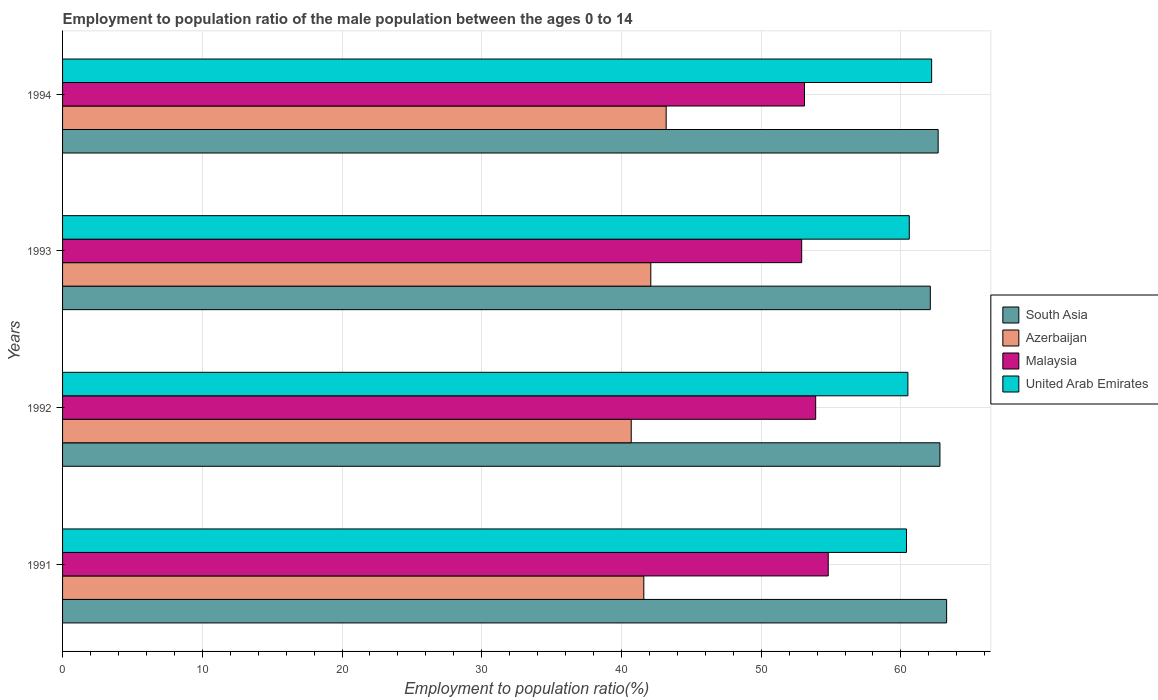How many groups of bars are there?
Offer a terse response. 4. How many bars are there on the 3rd tick from the top?
Your answer should be very brief. 4. In how many cases, is the number of bars for a given year not equal to the number of legend labels?
Keep it short and to the point. 0. What is the employment to population ratio in United Arab Emirates in 1992?
Keep it short and to the point. 60.5. Across all years, what is the maximum employment to population ratio in Malaysia?
Your answer should be compact. 54.8. Across all years, what is the minimum employment to population ratio in United Arab Emirates?
Ensure brevity in your answer.  60.4. In which year was the employment to population ratio in United Arab Emirates maximum?
Your answer should be very brief. 1994. What is the total employment to population ratio in South Asia in the graph?
Make the answer very short. 250.84. What is the difference between the employment to population ratio in Malaysia in 1992 and that in 1993?
Your answer should be very brief. 1. What is the difference between the employment to population ratio in United Arab Emirates in 1992 and the employment to population ratio in Malaysia in 1991?
Offer a very short reply. 5.7. What is the average employment to population ratio in United Arab Emirates per year?
Offer a very short reply. 60.93. In the year 1993, what is the difference between the employment to population ratio in United Arab Emirates and employment to population ratio in Malaysia?
Your answer should be very brief. 7.7. What is the ratio of the employment to population ratio in Malaysia in 1992 to that in 1994?
Ensure brevity in your answer.  1.02. Is the difference between the employment to population ratio in United Arab Emirates in 1991 and 1994 greater than the difference between the employment to population ratio in Malaysia in 1991 and 1994?
Your response must be concise. No. What is the difference between the highest and the second highest employment to population ratio in Azerbaijan?
Give a very brief answer. 1.1. What is the difference between the highest and the lowest employment to population ratio in Malaysia?
Give a very brief answer. 1.9. Is the sum of the employment to population ratio in Malaysia in 1992 and 1994 greater than the maximum employment to population ratio in Azerbaijan across all years?
Your answer should be very brief. Yes. What does the 4th bar from the top in 1991 represents?
Offer a very short reply. South Asia. What does the 3rd bar from the bottom in 1991 represents?
Offer a very short reply. Malaysia. How many bars are there?
Your answer should be compact. 16. Are all the bars in the graph horizontal?
Offer a terse response. Yes. What is the difference between two consecutive major ticks on the X-axis?
Offer a terse response. 10. Does the graph contain any zero values?
Make the answer very short. No. Where does the legend appear in the graph?
Provide a succinct answer. Center right. How many legend labels are there?
Provide a short and direct response. 4. What is the title of the graph?
Make the answer very short. Employment to population ratio of the male population between the ages 0 to 14. Does "North America" appear as one of the legend labels in the graph?
Your response must be concise. No. What is the Employment to population ratio(%) of South Asia in 1991?
Offer a very short reply. 63.27. What is the Employment to population ratio(%) of Azerbaijan in 1991?
Your answer should be very brief. 41.6. What is the Employment to population ratio(%) in Malaysia in 1991?
Provide a short and direct response. 54.8. What is the Employment to population ratio(%) in United Arab Emirates in 1991?
Make the answer very short. 60.4. What is the Employment to population ratio(%) of South Asia in 1992?
Keep it short and to the point. 62.79. What is the Employment to population ratio(%) of Azerbaijan in 1992?
Give a very brief answer. 40.7. What is the Employment to population ratio(%) of Malaysia in 1992?
Ensure brevity in your answer.  53.9. What is the Employment to population ratio(%) of United Arab Emirates in 1992?
Make the answer very short. 60.5. What is the Employment to population ratio(%) in South Asia in 1993?
Your answer should be very brief. 62.11. What is the Employment to population ratio(%) in Azerbaijan in 1993?
Your answer should be compact. 42.1. What is the Employment to population ratio(%) of Malaysia in 1993?
Provide a short and direct response. 52.9. What is the Employment to population ratio(%) of United Arab Emirates in 1993?
Give a very brief answer. 60.6. What is the Employment to population ratio(%) in South Asia in 1994?
Give a very brief answer. 62.67. What is the Employment to population ratio(%) in Azerbaijan in 1994?
Provide a succinct answer. 43.2. What is the Employment to population ratio(%) in Malaysia in 1994?
Your response must be concise. 53.1. What is the Employment to population ratio(%) of United Arab Emirates in 1994?
Give a very brief answer. 62.2. Across all years, what is the maximum Employment to population ratio(%) of South Asia?
Offer a very short reply. 63.27. Across all years, what is the maximum Employment to population ratio(%) in Azerbaijan?
Provide a short and direct response. 43.2. Across all years, what is the maximum Employment to population ratio(%) in Malaysia?
Your answer should be compact. 54.8. Across all years, what is the maximum Employment to population ratio(%) in United Arab Emirates?
Give a very brief answer. 62.2. Across all years, what is the minimum Employment to population ratio(%) in South Asia?
Ensure brevity in your answer.  62.11. Across all years, what is the minimum Employment to population ratio(%) in Azerbaijan?
Provide a short and direct response. 40.7. Across all years, what is the minimum Employment to population ratio(%) of Malaysia?
Your answer should be very brief. 52.9. Across all years, what is the minimum Employment to population ratio(%) of United Arab Emirates?
Your response must be concise. 60.4. What is the total Employment to population ratio(%) in South Asia in the graph?
Your answer should be compact. 250.84. What is the total Employment to population ratio(%) of Azerbaijan in the graph?
Your response must be concise. 167.6. What is the total Employment to population ratio(%) of Malaysia in the graph?
Your response must be concise. 214.7. What is the total Employment to population ratio(%) of United Arab Emirates in the graph?
Provide a short and direct response. 243.7. What is the difference between the Employment to population ratio(%) of South Asia in 1991 and that in 1992?
Provide a short and direct response. 0.48. What is the difference between the Employment to population ratio(%) of Malaysia in 1991 and that in 1992?
Make the answer very short. 0.9. What is the difference between the Employment to population ratio(%) in South Asia in 1991 and that in 1993?
Make the answer very short. 1.17. What is the difference between the Employment to population ratio(%) in United Arab Emirates in 1991 and that in 1993?
Your answer should be compact. -0.2. What is the difference between the Employment to population ratio(%) in South Asia in 1991 and that in 1994?
Make the answer very short. 0.61. What is the difference between the Employment to population ratio(%) of United Arab Emirates in 1991 and that in 1994?
Offer a terse response. -1.8. What is the difference between the Employment to population ratio(%) of South Asia in 1992 and that in 1993?
Your answer should be compact. 0.69. What is the difference between the Employment to population ratio(%) of Malaysia in 1992 and that in 1993?
Make the answer very short. 1. What is the difference between the Employment to population ratio(%) in South Asia in 1992 and that in 1994?
Your answer should be compact. 0.13. What is the difference between the Employment to population ratio(%) of Azerbaijan in 1992 and that in 1994?
Give a very brief answer. -2.5. What is the difference between the Employment to population ratio(%) in United Arab Emirates in 1992 and that in 1994?
Offer a terse response. -1.7. What is the difference between the Employment to population ratio(%) of South Asia in 1993 and that in 1994?
Provide a succinct answer. -0.56. What is the difference between the Employment to population ratio(%) of South Asia in 1991 and the Employment to population ratio(%) of Azerbaijan in 1992?
Provide a short and direct response. 22.57. What is the difference between the Employment to population ratio(%) of South Asia in 1991 and the Employment to population ratio(%) of Malaysia in 1992?
Offer a very short reply. 9.37. What is the difference between the Employment to population ratio(%) in South Asia in 1991 and the Employment to population ratio(%) in United Arab Emirates in 1992?
Make the answer very short. 2.77. What is the difference between the Employment to population ratio(%) of Azerbaijan in 1991 and the Employment to population ratio(%) of United Arab Emirates in 1992?
Your answer should be very brief. -18.9. What is the difference between the Employment to population ratio(%) of South Asia in 1991 and the Employment to population ratio(%) of Azerbaijan in 1993?
Your answer should be very brief. 21.17. What is the difference between the Employment to population ratio(%) in South Asia in 1991 and the Employment to population ratio(%) in Malaysia in 1993?
Give a very brief answer. 10.37. What is the difference between the Employment to population ratio(%) of South Asia in 1991 and the Employment to population ratio(%) of United Arab Emirates in 1993?
Make the answer very short. 2.67. What is the difference between the Employment to population ratio(%) of Azerbaijan in 1991 and the Employment to population ratio(%) of Malaysia in 1993?
Give a very brief answer. -11.3. What is the difference between the Employment to population ratio(%) of Azerbaijan in 1991 and the Employment to population ratio(%) of United Arab Emirates in 1993?
Ensure brevity in your answer.  -19. What is the difference between the Employment to population ratio(%) of Malaysia in 1991 and the Employment to population ratio(%) of United Arab Emirates in 1993?
Make the answer very short. -5.8. What is the difference between the Employment to population ratio(%) of South Asia in 1991 and the Employment to population ratio(%) of Azerbaijan in 1994?
Your answer should be very brief. 20.07. What is the difference between the Employment to population ratio(%) in South Asia in 1991 and the Employment to population ratio(%) in Malaysia in 1994?
Offer a terse response. 10.17. What is the difference between the Employment to population ratio(%) in South Asia in 1991 and the Employment to population ratio(%) in United Arab Emirates in 1994?
Make the answer very short. 1.07. What is the difference between the Employment to population ratio(%) of Azerbaijan in 1991 and the Employment to population ratio(%) of United Arab Emirates in 1994?
Offer a terse response. -20.6. What is the difference between the Employment to population ratio(%) in Malaysia in 1991 and the Employment to population ratio(%) in United Arab Emirates in 1994?
Provide a short and direct response. -7.4. What is the difference between the Employment to population ratio(%) of South Asia in 1992 and the Employment to population ratio(%) of Azerbaijan in 1993?
Give a very brief answer. 20.69. What is the difference between the Employment to population ratio(%) in South Asia in 1992 and the Employment to population ratio(%) in Malaysia in 1993?
Your answer should be compact. 9.89. What is the difference between the Employment to population ratio(%) in South Asia in 1992 and the Employment to population ratio(%) in United Arab Emirates in 1993?
Give a very brief answer. 2.19. What is the difference between the Employment to population ratio(%) of Azerbaijan in 1992 and the Employment to population ratio(%) of Malaysia in 1993?
Your answer should be very brief. -12.2. What is the difference between the Employment to population ratio(%) of Azerbaijan in 1992 and the Employment to population ratio(%) of United Arab Emirates in 1993?
Keep it short and to the point. -19.9. What is the difference between the Employment to population ratio(%) in South Asia in 1992 and the Employment to population ratio(%) in Azerbaijan in 1994?
Provide a short and direct response. 19.59. What is the difference between the Employment to population ratio(%) in South Asia in 1992 and the Employment to population ratio(%) in Malaysia in 1994?
Your answer should be compact. 9.69. What is the difference between the Employment to population ratio(%) in South Asia in 1992 and the Employment to population ratio(%) in United Arab Emirates in 1994?
Make the answer very short. 0.59. What is the difference between the Employment to population ratio(%) of Azerbaijan in 1992 and the Employment to population ratio(%) of Malaysia in 1994?
Your answer should be compact. -12.4. What is the difference between the Employment to population ratio(%) of Azerbaijan in 1992 and the Employment to population ratio(%) of United Arab Emirates in 1994?
Ensure brevity in your answer.  -21.5. What is the difference between the Employment to population ratio(%) of Malaysia in 1992 and the Employment to population ratio(%) of United Arab Emirates in 1994?
Offer a terse response. -8.3. What is the difference between the Employment to population ratio(%) in South Asia in 1993 and the Employment to population ratio(%) in Azerbaijan in 1994?
Offer a very short reply. 18.91. What is the difference between the Employment to population ratio(%) in South Asia in 1993 and the Employment to population ratio(%) in Malaysia in 1994?
Keep it short and to the point. 9.01. What is the difference between the Employment to population ratio(%) of South Asia in 1993 and the Employment to population ratio(%) of United Arab Emirates in 1994?
Offer a terse response. -0.09. What is the difference between the Employment to population ratio(%) in Azerbaijan in 1993 and the Employment to population ratio(%) in Malaysia in 1994?
Your response must be concise. -11. What is the difference between the Employment to population ratio(%) in Azerbaijan in 1993 and the Employment to population ratio(%) in United Arab Emirates in 1994?
Give a very brief answer. -20.1. What is the difference between the Employment to population ratio(%) of Malaysia in 1993 and the Employment to population ratio(%) of United Arab Emirates in 1994?
Make the answer very short. -9.3. What is the average Employment to population ratio(%) in South Asia per year?
Ensure brevity in your answer.  62.71. What is the average Employment to population ratio(%) of Azerbaijan per year?
Provide a short and direct response. 41.9. What is the average Employment to population ratio(%) in Malaysia per year?
Keep it short and to the point. 53.67. What is the average Employment to population ratio(%) in United Arab Emirates per year?
Offer a terse response. 60.92. In the year 1991, what is the difference between the Employment to population ratio(%) of South Asia and Employment to population ratio(%) of Azerbaijan?
Provide a succinct answer. 21.67. In the year 1991, what is the difference between the Employment to population ratio(%) of South Asia and Employment to population ratio(%) of Malaysia?
Your answer should be very brief. 8.47. In the year 1991, what is the difference between the Employment to population ratio(%) in South Asia and Employment to population ratio(%) in United Arab Emirates?
Offer a very short reply. 2.87. In the year 1991, what is the difference between the Employment to population ratio(%) of Azerbaijan and Employment to population ratio(%) of United Arab Emirates?
Provide a succinct answer. -18.8. In the year 1991, what is the difference between the Employment to population ratio(%) of Malaysia and Employment to population ratio(%) of United Arab Emirates?
Ensure brevity in your answer.  -5.6. In the year 1992, what is the difference between the Employment to population ratio(%) in South Asia and Employment to population ratio(%) in Azerbaijan?
Keep it short and to the point. 22.09. In the year 1992, what is the difference between the Employment to population ratio(%) in South Asia and Employment to population ratio(%) in Malaysia?
Keep it short and to the point. 8.89. In the year 1992, what is the difference between the Employment to population ratio(%) of South Asia and Employment to population ratio(%) of United Arab Emirates?
Provide a short and direct response. 2.29. In the year 1992, what is the difference between the Employment to population ratio(%) in Azerbaijan and Employment to population ratio(%) in Malaysia?
Provide a short and direct response. -13.2. In the year 1992, what is the difference between the Employment to population ratio(%) of Azerbaijan and Employment to population ratio(%) of United Arab Emirates?
Provide a short and direct response. -19.8. In the year 1992, what is the difference between the Employment to population ratio(%) in Malaysia and Employment to population ratio(%) in United Arab Emirates?
Your answer should be compact. -6.6. In the year 1993, what is the difference between the Employment to population ratio(%) in South Asia and Employment to population ratio(%) in Azerbaijan?
Your answer should be compact. 20.01. In the year 1993, what is the difference between the Employment to population ratio(%) in South Asia and Employment to population ratio(%) in Malaysia?
Offer a terse response. 9.21. In the year 1993, what is the difference between the Employment to population ratio(%) in South Asia and Employment to population ratio(%) in United Arab Emirates?
Give a very brief answer. 1.51. In the year 1993, what is the difference between the Employment to population ratio(%) in Azerbaijan and Employment to population ratio(%) in United Arab Emirates?
Provide a short and direct response. -18.5. In the year 1993, what is the difference between the Employment to population ratio(%) in Malaysia and Employment to population ratio(%) in United Arab Emirates?
Your answer should be very brief. -7.7. In the year 1994, what is the difference between the Employment to population ratio(%) of South Asia and Employment to population ratio(%) of Azerbaijan?
Your answer should be very brief. 19.47. In the year 1994, what is the difference between the Employment to population ratio(%) in South Asia and Employment to population ratio(%) in Malaysia?
Make the answer very short. 9.57. In the year 1994, what is the difference between the Employment to population ratio(%) of South Asia and Employment to population ratio(%) of United Arab Emirates?
Provide a short and direct response. 0.47. In the year 1994, what is the difference between the Employment to population ratio(%) in Azerbaijan and Employment to population ratio(%) in Malaysia?
Ensure brevity in your answer.  -9.9. In the year 1994, what is the difference between the Employment to population ratio(%) of Azerbaijan and Employment to population ratio(%) of United Arab Emirates?
Make the answer very short. -19. What is the ratio of the Employment to population ratio(%) of South Asia in 1991 to that in 1992?
Ensure brevity in your answer.  1.01. What is the ratio of the Employment to population ratio(%) of Azerbaijan in 1991 to that in 1992?
Keep it short and to the point. 1.02. What is the ratio of the Employment to population ratio(%) in Malaysia in 1991 to that in 1992?
Give a very brief answer. 1.02. What is the ratio of the Employment to population ratio(%) of South Asia in 1991 to that in 1993?
Ensure brevity in your answer.  1.02. What is the ratio of the Employment to population ratio(%) of Malaysia in 1991 to that in 1993?
Provide a succinct answer. 1.04. What is the ratio of the Employment to population ratio(%) in United Arab Emirates in 1991 to that in 1993?
Give a very brief answer. 1. What is the ratio of the Employment to population ratio(%) in South Asia in 1991 to that in 1994?
Ensure brevity in your answer.  1.01. What is the ratio of the Employment to population ratio(%) of Azerbaijan in 1991 to that in 1994?
Ensure brevity in your answer.  0.96. What is the ratio of the Employment to population ratio(%) in Malaysia in 1991 to that in 1994?
Give a very brief answer. 1.03. What is the ratio of the Employment to population ratio(%) in United Arab Emirates in 1991 to that in 1994?
Your answer should be very brief. 0.97. What is the ratio of the Employment to population ratio(%) in South Asia in 1992 to that in 1993?
Give a very brief answer. 1.01. What is the ratio of the Employment to population ratio(%) in Azerbaijan in 1992 to that in 1993?
Offer a very short reply. 0.97. What is the ratio of the Employment to population ratio(%) in Malaysia in 1992 to that in 1993?
Give a very brief answer. 1.02. What is the ratio of the Employment to population ratio(%) in Azerbaijan in 1992 to that in 1994?
Give a very brief answer. 0.94. What is the ratio of the Employment to population ratio(%) in Malaysia in 1992 to that in 1994?
Make the answer very short. 1.02. What is the ratio of the Employment to population ratio(%) of United Arab Emirates in 1992 to that in 1994?
Ensure brevity in your answer.  0.97. What is the ratio of the Employment to population ratio(%) in Azerbaijan in 1993 to that in 1994?
Your answer should be very brief. 0.97. What is the ratio of the Employment to population ratio(%) of United Arab Emirates in 1993 to that in 1994?
Provide a succinct answer. 0.97. What is the difference between the highest and the second highest Employment to population ratio(%) of South Asia?
Ensure brevity in your answer.  0.48. What is the difference between the highest and the second highest Employment to population ratio(%) in Azerbaijan?
Offer a very short reply. 1.1. What is the difference between the highest and the second highest Employment to population ratio(%) of Malaysia?
Ensure brevity in your answer.  0.9. What is the difference between the highest and the lowest Employment to population ratio(%) of South Asia?
Give a very brief answer. 1.17. What is the difference between the highest and the lowest Employment to population ratio(%) in Azerbaijan?
Your answer should be compact. 2.5. What is the difference between the highest and the lowest Employment to population ratio(%) of Malaysia?
Ensure brevity in your answer.  1.9. What is the difference between the highest and the lowest Employment to population ratio(%) in United Arab Emirates?
Your response must be concise. 1.8. 